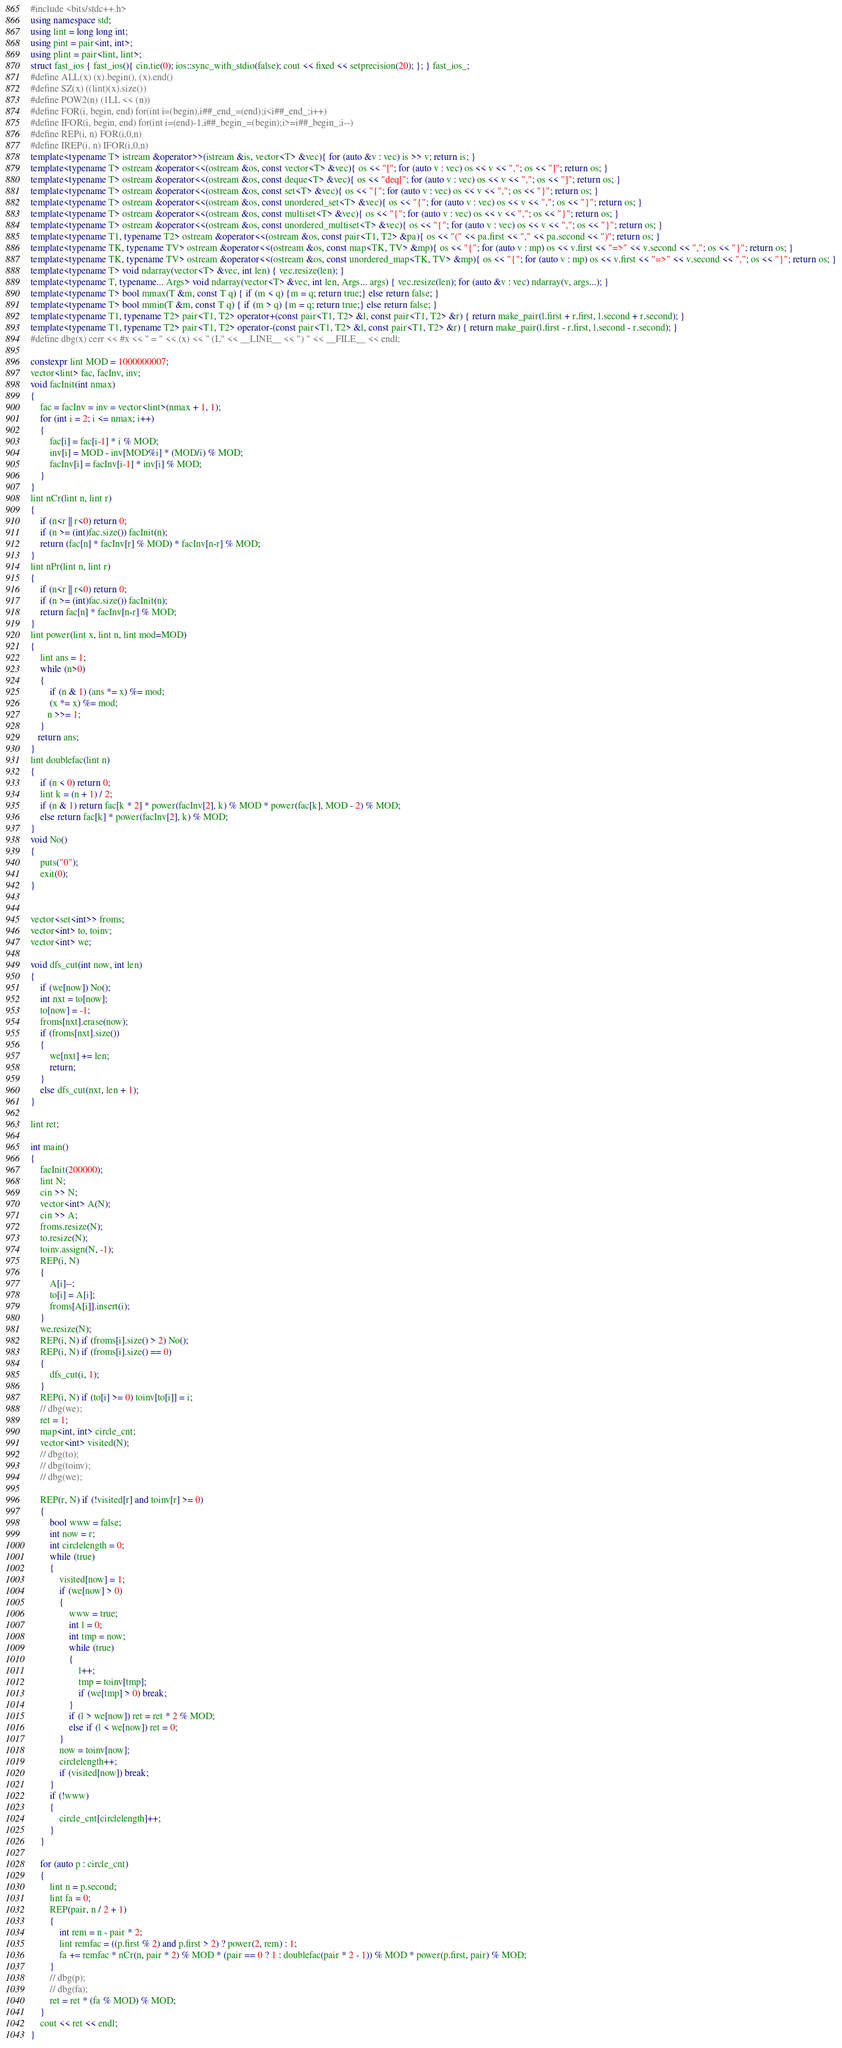<code> <loc_0><loc_0><loc_500><loc_500><_C++_>#include <bits/stdc++.h>
using namespace std;
using lint = long long int;
using pint = pair<int, int>;
using plint = pair<lint, lint>;
struct fast_ios { fast_ios(){ cin.tie(0); ios::sync_with_stdio(false); cout << fixed << setprecision(20); }; } fast_ios_;
#define ALL(x) (x).begin(), (x).end()
#define SZ(x) ((lint)(x).size())
#define POW2(n) (1LL << (n))
#define FOR(i, begin, end) for(int i=(begin),i##_end_=(end);i<i##_end_;i++)
#define IFOR(i, begin, end) for(int i=(end)-1,i##_begin_=(begin);i>=i##_begin_;i--)
#define REP(i, n) FOR(i,0,n)
#define IREP(i, n) IFOR(i,0,n)
template<typename T> istream &operator>>(istream &is, vector<T> &vec){ for (auto &v : vec) is >> v; return is; }
template<typename T> ostream &operator<<(ostream &os, const vector<T> &vec){ os << "["; for (auto v : vec) os << v << ","; os << "]"; return os; }
template<typename T> ostream &operator<<(ostream &os, const deque<T> &vec){ os << "deq["; for (auto v : vec) os << v << ","; os << "]"; return os; }
template<typename T> ostream &operator<<(ostream &os, const set<T> &vec){ os << "{"; for (auto v : vec) os << v << ","; os << "}"; return os; }
template<typename T> ostream &operator<<(ostream &os, const unordered_set<T> &vec){ os << "{"; for (auto v : vec) os << v << ","; os << "}"; return os; }
template<typename T> ostream &operator<<(ostream &os, const multiset<T> &vec){ os << "{"; for (auto v : vec) os << v << ","; os << "}"; return os; }
template<typename T> ostream &operator<<(ostream &os, const unordered_multiset<T> &vec){ os << "{"; for (auto v : vec) os << v << ","; os << "}"; return os; }
template<typename T1, typename T2> ostream &operator<<(ostream &os, const pair<T1, T2> &pa){ os << "(" << pa.first << "," << pa.second << ")"; return os; }
template<typename TK, typename TV> ostream &operator<<(ostream &os, const map<TK, TV> &mp){ os << "{"; for (auto v : mp) os << v.first << "=>" << v.second << ","; os << "}"; return os; }
template<typename TK, typename TV> ostream &operator<<(ostream &os, const unordered_map<TK, TV> &mp){ os << "{"; for (auto v : mp) os << v.first << "=>" << v.second << ","; os << "}"; return os; }
template<typename T> void ndarray(vector<T> &vec, int len) { vec.resize(len); }
template<typename T, typename... Args> void ndarray(vector<T> &vec, int len, Args... args) { vec.resize(len); for (auto &v : vec) ndarray(v, args...); }
template<typename T> bool mmax(T &m, const T q) { if (m < q) {m = q; return true;} else return false; }
template<typename T> bool mmin(T &m, const T q) { if (m > q) {m = q; return true;} else return false; }
template<typename T1, typename T2> pair<T1, T2> operator+(const pair<T1, T2> &l, const pair<T1, T2> &r) { return make_pair(l.first + r.first, l.second + r.second); }
template<typename T1, typename T2> pair<T1, T2> operator-(const pair<T1, T2> &l, const pair<T1, T2> &r) { return make_pair(l.first - r.first, l.second - r.second); }
#define dbg(x) cerr << #x << " = " << (x) << " (L" << __LINE__ << ") " << __FILE__ << endl;

constexpr lint MOD = 1000000007;
vector<lint> fac, facInv, inv;
void facInit(int nmax)
{
    fac = facInv = inv = vector<lint>(nmax + 1, 1);
    for (int i = 2; i <= nmax; i++)
    {
        fac[i] = fac[i-1] * i % MOD;
        inv[i] = MOD - inv[MOD%i] * (MOD/i) % MOD;
        facInv[i] = facInv[i-1] * inv[i] % MOD;
    }
}
lint nCr(lint n, lint r)
{
    if (n<r || r<0) return 0;
    if (n >= (int)fac.size()) facInit(n);
    return (fac[n] * facInv[r] % MOD) * facInv[n-r] % MOD;
}
lint nPr(lint n, lint r)
{
    if (n<r || r<0) return 0;
    if (n >= (int)fac.size()) facInit(n);
    return fac[n] * facInv[n-r] % MOD;
}
lint power(lint x, lint n, lint mod=MOD)
{
    lint ans = 1;
    while (n>0)
    {
        if (n & 1) (ans *= x) %= mod;
        (x *= x) %= mod;
       n >>= 1;
    }
   return ans;
}
lint doublefac(lint n)
{
    if (n < 0) return 0;
    lint k = (n + 1) / 2;
    if (n & 1) return fac[k * 2] * power(facInv[2], k) % MOD * power(fac[k], MOD - 2) % MOD;
    else return fac[k] * power(facInv[2], k) % MOD;
}
void No()
{
    puts("0");
    exit(0);
}


vector<set<int>> froms;
vector<int> to, toinv;
vector<int> we;

void dfs_cut(int now, int len)
{
    if (we[now]) No();
    int nxt = to[now];
    to[now] = -1;
    froms[nxt].erase(now);
    if (froms[nxt].size())
    {
        we[nxt] += len;
        return;
    }
    else dfs_cut(nxt, len + 1);
}

lint ret;

int main()
{
    facInit(200000);
    lint N;
    cin >> N;
    vector<int> A(N);
    cin >> A;
    froms.resize(N);
    to.resize(N);
    toinv.assign(N, -1);
    REP(i, N)
    {
        A[i]--;
        to[i] = A[i];
        froms[A[i]].insert(i);
    }
    we.resize(N);
    REP(i, N) if (froms[i].size() > 2) No();
    REP(i, N) if (froms[i].size() == 0)
    {
        dfs_cut(i, 1);
    }
    REP(i, N) if (to[i] >= 0) toinv[to[i]] = i;
    // dbg(we);
    ret = 1;
    map<int, int> circle_cnt;
    vector<int> visited(N);
    // dbg(to);
    // dbg(toinv);
    // dbg(we);

    REP(r, N) if (!visited[r] and toinv[r] >= 0)
    {
        bool www = false;
        int now = r;
        int circlelength = 0;
        while (true)
        {
            visited[now] = 1;
            if (we[now] > 0)
            {
                www = true;
                int l = 0;
                int tmp = now;
                while (true)
                {
                    l++;
                    tmp = toinv[tmp];
                    if (we[tmp] > 0) break;
                }
                if (l > we[now]) ret = ret * 2 % MOD;
                else if (l < we[now]) ret = 0;
            }
            now = toinv[now];
            circlelength++;
            if (visited[now]) break;
        }
        if (!www)
        {
            circle_cnt[circlelength]++;
        }
    }

    for (auto p : circle_cnt)
    {
        lint n = p.second;
        lint fa = 0;
        REP(pair, n / 2 + 1)
        {
            int rem = n - pair * 2;
            lint remfac = ((p.first % 2) and p.first > 2) ? power(2, rem) : 1;
            fa += remfac * nCr(n, pair * 2) % MOD * (pair == 0 ? 1 : doublefac(pair * 2 - 1)) % MOD * power(p.first, pair) % MOD;
        }
        // dbg(p);
        // dbg(fa);
        ret = ret * (fa % MOD) % MOD;
    }
    cout << ret << endl;
}
</code> 